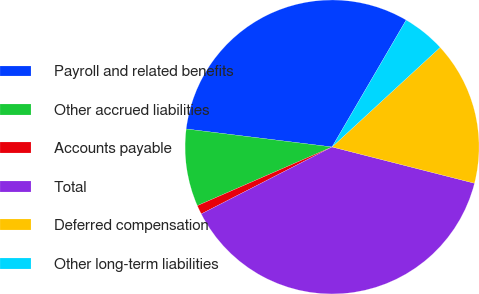<chart> <loc_0><loc_0><loc_500><loc_500><pie_chart><fcel>Payroll and related benefits<fcel>Other accrued liabilities<fcel>Accounts payable<fcel>Total<fcel>Deferred compensation<fcel>Other long-term liabilities<nl><fcel>31.46%<fcel>8.49%<fcel>0.99%<fcel>38.5%<fcel>15.82%<fcel>4.74%<nl></chart> 